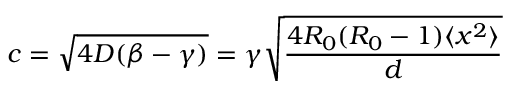Convert formula to latex. <formula><loc_0><loc_0><loc_500><loc_500>c = \sqrt { 4 D ( \beta - \gamma ) } = \gamma \sqrt { \frac { 4 R _ { 0 } ( R _ { 0 } - 1 ) \langle x ^ { 2 } \rangle } { d } }</formula> 